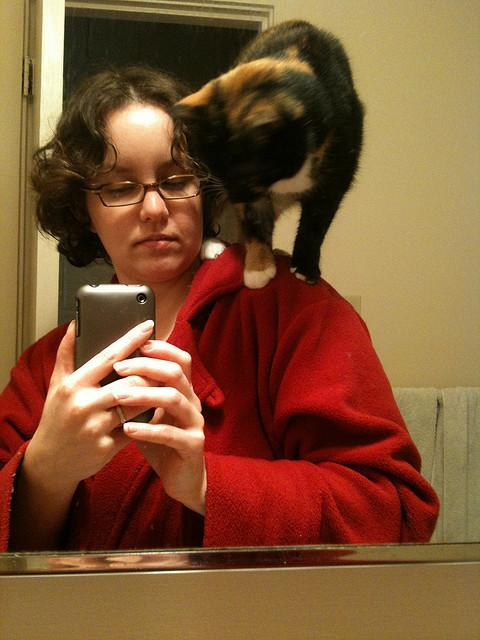What bathroom fixture is located in front of the woman at waist height?

Choices:
A) sink
B) hamper
C) toilet
D) towel rack sink 